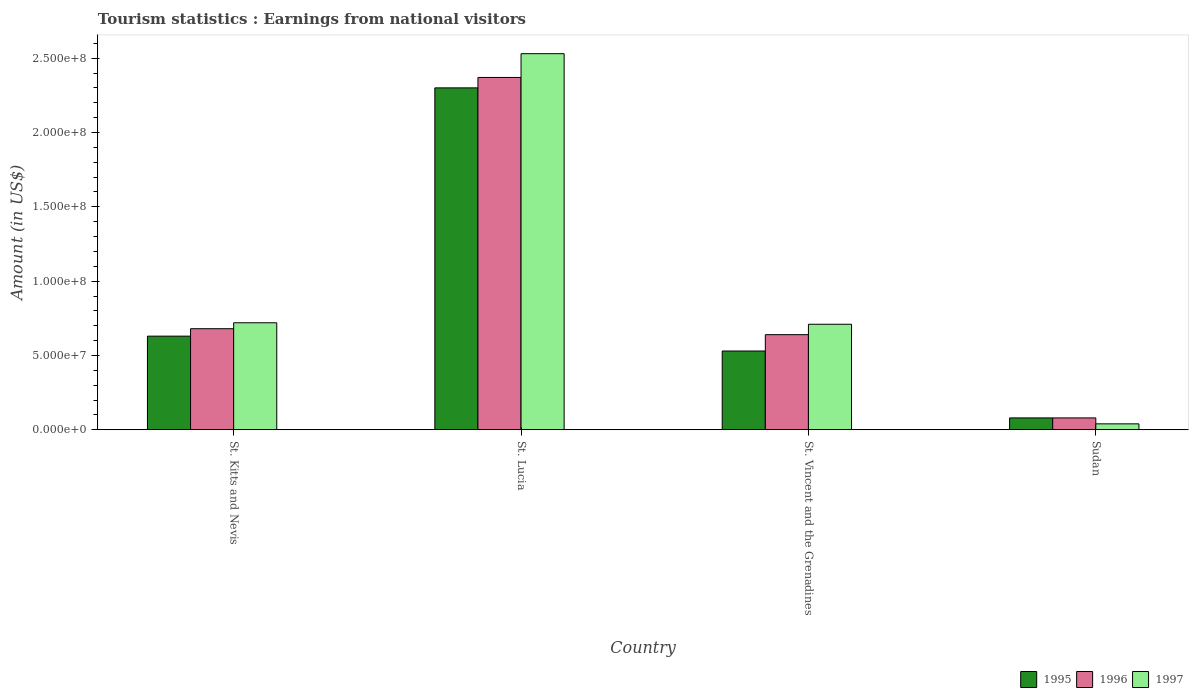How many different coloured bars are there?
Offer a very short reply. 3. How many groups of bars are there?
Ensure brevity in your answer.  4. How many bars are there on the 3rd tick from the right?
Your answer should be very brief. 3. What is the label of the 1st group of bars from the left?
Make the answer very short. St. Kitts and Nevis. Across all countries, what is the maximum earnings from national visitors in 1996?
Your answer should be very brief. 2.37e+08. Across all countries, what is the minimum earnings from national visitors in 1996?
Make the answer very short. 8.00e+06. In which country was the earnings from national visitors in 1997 maximum?
Make the answer very short. St. Lucia. In which country was the earnings from national visitors in 1995 minimum?
Offer a very short reply. Sudan. What is the total earnings from national visitors in 1997 in the graph?
Your response must be concise. 4.00e+08. What is the difference between the earnings from national visitors in 1997 in St. Lucia and that in Sudan?
Your answer should be compact. 2.49e+08. What is the difference between the earnings from national visitors in 1996 in St. Vincent and the Grenadines and the earnings from national visitors in 1997 in Sudan?
Provide a short and direct response. 6.00e+07. What is the average earnings from national visitors in 1995 per country?
Your answer should be very brief. 8.85e+07. What is the difference between the earnings from national visitors of/in 1995 and earnings from national visitors of/in 1996 in St. Kitts and Nevis?
Keep it short and to the point. -5.00e+06. What is the ratio of the earnings from national visitors in 1995 in St. Kitts and Nevis to that in Sudan?
Provide a short and direct response. 7.88. What is the difference between the highest and the second highest earnings from national visitors in 1995?
Your answer should be very brief. 1.77e+08. What is the difference between the highest and the lowest earnings from national visitors in 1996?
Offer a very short reply. 2.29e+08. Is the sum of the earnings from national visitors in 1996 in St. Lucia and St. Vincent and the Grenadines greater than the maximum earnings from national visitors in 1995 across all countries?
Provide a short and direct response. Yes. Is it the case that in every country, the sum of the earnings from national visitors in 1997 and earnings from national visitors in 1996 is greater than the earnings from national visitors in 1995?
Give a very brief answer. Yes. How many bars are there?
Ensure brevity in your answer.  12. How many countries are there in the graph?
Keep it short and to the point. 4. Does the graph contain any zero values?
Give a very brief answer. No. Does the graph contain grids?
Provide a succinct answer. No. Where does the legend appear in the graph?
Offer a very short reply. Bottom right. How many legend labels are there?
Make the answer very short. 3. What is the title of the graph?
Your answer should be compact. Tourism statistics : Earnings from national visitors. What is the label or title of the X-axis?
Your answer should be very brief. Country. What is the label or title of the Y-axis?
Your answer should be compact. Amount (in US$). What is the Amount (in US$) in 1995 in St. Kitts and Nevis?
Give a very brief answer. 6.30e+07. What is the Amount (in US$) in 1996 in St. Kitts and Nevis?
Ensure brevity in your answer.  6.80e+07. What is the Amount (in US$) in 1997 in St. Kitts and Nevis?
Keep it short and to the point. 7.20e+07. What is the Amount (in US$) in 1995 in St. Lucia?
Your answer should be very brief. 2.30e+08. What is the Amount (in US$) in 1996 in St. Lucia?
Offer a very short reply. 2.37e+08. What is the Amount (in US$) in 1997 in St. Lucia?
Offer a very short reply. 2.53e+08. What is the Amount (in US$) in 1995 in St. Vincent and the Grenadines?
Offer a terse response. 5.30e+07. What is the Amount (in US$) in 1996 in St. Vincent and the Grenadines?
Offer a very short reply. 6.40e+07. What is the Amount (in US$) of 1997 in St. Vincent and the Grenadines?
Provide a short and direct response. 7.10e+07. What is the Amount (in US$) in 1995 in Sudan?
Offer a terse response. 8.00e+06. Across all countries, what is the maximum Amount (in US$) in 1995?
Your answer should be compact. 2.30e+08. Across all countries, what is the maximum Amount (in US$) in 1996?
Offer a very short reply. 2.37e+08. Across all countries, what is the maximum Amount (in US$) in 1997?
Provide a succinct answer. 2.53e+08. Across all countries, what is the minimum Amount (in US$) of 1996?
Your answer should be compact. 8.00e+06. Across all countries, what is the minimum Amount (in US$) of 1997?
Ensure brevity in your answer.  4.00e+06. What is the total Amount (in US$) in 1995 in the graph?
Your answer should be very brief. 3.54e+08. What is the total Amount (in US$) in 1996 in the graph?
Offer a terse response. 3.77e+08. What is the total Amount (in US$) of 1997 in the graph?
Offer a terse response. 4.00e+08. What is the difference between the Amount (in US$) in 1995 in St. Kitts and Nevis and that in St. Lucia?
Your answer should be very brief. -1.67e+08. What is the difference between the Amount (in US$) in 1996 in St. Kitts and Nevis and that in St. Lucia?
Give a very brief answer. -1.69e+08. What is the difference between the Amount (in US$) in 1997 in St. Kitts and Nevis and that in St. Lucia?
Ensure brevity in your answer.  -1.81e+08. What is the difference between the Amount (in US$) in 1995 in St. Kitts and Nevis and that in St. Vincent and the Grenadines?
Offer a very short reply. 1.00e+07. What is the difference between the Amount (in US$) of 1996 in St. Kitts and Nevis and that in St. Vincent and the Grenadines?
Your response must be concise. 4.00e+06. What is the difference between the Amount (in US$) in 1995 in St. Kitts and Nevis and that in Sudan?
Offer a terse response. 5.50e+07. What is the difference between the Amount (in US$) of 1996 in St. Kitts and Nevis and that in Sudan?
Offer a terse response. 6.00e+07. What is the difference between the Amount (in US$) of 1997 in St. Kitts and Nevis and that in Sudan?
Your answer should be very brief. 6.80e+07. What is the difference between the Amount (in US$) in 1995 in St. Lucia and that in St. Vincent and the Grenadines?
Make the answer very short. 1.77e+08. What is the difference between the Amount (in US$) of 1996 in St. Lucia and that in St. Vincent and the Grenadines?
Offer a very short reply. 1.73e+08. What is the difference between the Amount (in US$) of 1997 in St. Lucia and that in St. Vincent and the Grenadines?
Ensure brevity in your answer.  1.82e+08. What is the difference between the Amount (in US$) of 1995 in St. Lucia and that in Sudan?
Provide a short and direct response. 2.22e+08. What is the difference between the Amount (in US$) of 1996 in St. Lucia and that in Sudan?
Your answer should be very brief. 2.29e+08. What is the difference between the Amount (in US$) of 1997 in St. Lucia and that in Sudan?
Keep it short and to the point. 2.49e+08. What is the difference between the Amount (in US$) of 1995 in St. Vincent and the Grenadines and that in Sudan?
Offer a terse response. 4.50e+07. What is the difference between the Amount (in US$) in 1996 in St. Vincent and the Grenadines and that in Sudan?
Ensure brevity in your answer.  5.60e+07. What is the difference between the Amount (in US$) of 1997 in St. Vincent and the Grenadines and that in Sudan?
Provide a succinct answer. 6.70e+07. What is the difference between the Amount (in US$) of 1995 in St. Kitts and Nevis and the Amount (in US$) of 1996 in St. Lucia?
Your response must be concise. -1.74e+08. What is the difference between the Amount (in US$) in 1995 in St. Kitts and Nevis and the Amount (in US$) in 1997 in St. Lucia?
Provide a short and direct response. -1.90e+08. What is the difference between the Amount (in US$) of 1996 in St. Kitts and Nevis and the Amount (in US$) of 1997 in St. Lucia?
Your answer should be compact. -1.85e+08. What is the difference between the Amount (in US$) in 1995 in St. Kitts and Nevis and the Amount (in US$) in 1996 in St. Vincent and the Grenadines?
Give a very brief answer. -1.00e+06. What is the difference between the Amount (in US$) of 1995 in St. Kitts and Nevis and the Amount (in US$) of 1997 in St. Vincent and the Grenadines?
Ensure brevity in your answer.  -8.00e+06. What is the difference between the Amount (in US$) in 1995 in St. Kitts and Nevis and the Amount (in US$) in 1996 in Sudan?
Your answer should be very brief. 5.50e+07. What is the difference between the Amount (in US$) of 1995 in St. Kitts and Nevis and the Amount (in US$) of 1997 in Sudan?
Keep it short and to the point. 5.90e+07. What is the difference between the Amount (in US$) of 1996 in St. Kitts and Nevis and the Amount (in US$) of 1997 in Sudan?
Keep it short and to the point. 6.40e+07. What is the difference between the Amount (in US$) of 1995 in St. Lucia and the Amount (in US$) of 1996 in St. Vincent and the Grenadines?
Your answer should be compact. 1.66e+08. What is the difference between the Amount (in US$) of 1995 in St. Lucia and the Amount (in US$) of 1997 in St. Vincent and the Grenadines?
Give a very brief answer. 1.59e+08. What is the difference between the Amount (in US$) of 1996 in St. Lucia and the Amount (in US$) of 1997 in St. Vincent and the Grenadines?
Your answer should be very brief. 1.66e+08. What is the difference between the Amount (in US$) in 1995 in St. Lucia and the Amount (in US$) in 1996 in Sudan?
Offer a terse response. 2.22e+08. What is the difference between the Amount (in US$) in 1995 in St. Lucia and the Amount (in US$) in 1997 in Sudan?
Your answer should be very brief. 2.26e+08. What is the difference between the Amount (in US$) of 1996 in St. Lucia and the Amount (in US$) of 1997 in Sudan?
Make the answer very short. 2.33e+08. What is the difference between the Amount (in US$) of 1995 in St. Vincent and the Grenadines and the Amount (in US$) of 1996 in Sudan?
Your answer should be very brief. 4.50e+07. What is the difference between the Amount (in US$) in 1995 in St. Vincent and the Grenadines and the Amount (in US$) in 1997 in Sudan?
Your answer should be compact. 4.90e+07. What is the difference between the Amount (in US$) in 1996 in St. Vincent and the Grenadines and the Amount (in US$) in 1997 in Sudan?
Provide a succinct answer. 6.00e+07. What is the average Amount (in US$) of 1995 per country?
Your answer should be very brief. 8.85e+07. What is the average Amount (in US$) of 1996 per country?
Your answer should be very brief. 9.42e+07. What is the average Amount (in US$) of 1997 per country?
Provide a short and direct response. 1.00e+08. What is the difference between the Amount (in US$) of 1995 and Amount (in US$) of 1996 in St. Kitts and Nevis?
Your response must be concise. -5.00e+06. What is the difference between the Amount (in US$) in 1995 and Amount (in US$) in 1997 in St. Kitts and Nevis?
Offer a very short reply. -9.00e+06. What is the difference between the Amount (in US$) of 1995 and Amount (in US$) of 1996 in St. Lucia?
Make the answer very short. -7.00e+06. What is the difference between the Amount (in US$) in 1995 and Amount (in US$) in 1997 in St. Lucia?
Keep it short and to the point. -2.30e+07. What is the difference between the Amount (in US$) in 1996 and Amount (in US$) in 1997 in St. Lucia?
Your answer should be very brief. -1.60e+07. What is the difference between the Amount (in US$) in 1995 and Amount (in US$) in 1996 in St. Vincent and the Grenadines?
Your answer should be very brief. -1.10e+07. What is the difference between the Amount (in US$) in 1995 and Amount (in US$) in 1997 in St. Vincent and the Grenadines?
Keep it short and to the point. -1.80e+07. What is the difference between the Amount (in US$) of 1996 and Amount (in US$) of 1997 in St. Vincent and the Grenadines?
Make the answer very short. -7.00e+06. What is the difference between the Amount (in US$) of 1995 and Amount (in US$) of 1997 in Sudan?
Keep it short and to the point. 4.00e+06. What is the difference between the Amount (in US$) in 1996 and Amount (in US$) in 1997 in Sudan?
Provide a short and direct response. 4.00e+06. What is the ratio of the Amount (in US$) in 1995 in St. Kitts and Nevis to that in St. Lucia?
Your response must be concise. 0.27. What is the ratio of the Amount (in US$) of 1996 in St. Kitts and Nevis to that in St. Lucia?
Offer a very short reply. 0.29. What is the ratio of the Amount (in US$) of 1997 in St. Kitts and Nevis to that in St. Lucia?
Ensure brevity in your answer.  0.28. What is the ratio of the Amount (in US$) of 1995 in St. Kitts and Nevis to that in St. Vincent and the Grenadines?
Give a very brief answer. 1.19. What is the ratio of the Amount (in US$) of 1996 in St. Kitts and Nevis to that in St. Vincent and the Grenadines?
Your answer should be compact. 1.06. What is the ratio of the Amount (in US$) of 1997 in St. Kitts and Nevis to that in St. Vincent and the Grenadines?
Provide a succinct answer. 1.01. What is the ratio of the Amount (in US$) of 1995 in St. Kitts and Nevis to that in Sudan?
Your response must be concise. 7.88. What is the ratio of the Amount (in US$) of 1996 in St. Kitts and Nevis to that in Sudan?
Give a very brief answer. 8.5. What is the ratio of the Amount (in US$) in 1995 in St. Lucia to that in St. Vincent and the Grenadines?
Offer a very short reply. 4.34. What is the ratio of the Amount (in US$) in 1996 in St. Lucia to that in St. Vincent and the Grenadines?
Provide a short and direct response. 3.7. What is the ratio of the Amount (in US$) of 1997 in St. Lucia to that in St. Vincent and the Grenadines?
Offer a very short reply. 3.56. What is the ratio of the Amount (in US$) of 1995 in St. Lucia to that in Sudan?
Your response must be concise. 28.75. What is the ratio of the Amount (in US$) of 1996 in St. Lucia to that in Sudan?
Your response must be concise. 29.62. What is the ratio of the Amount (in US$) of 1997 in St. Lucia to that in Sudan?
Offer a terse response. 63.25. What is the ratio of the Amount (in US$) of 1995 in St. Vincent and the Grenadines to that in Sudan?
Ensure brevity in your answer.  6.62. What is the ratio of the Amount (in US$) of 1997 in St. Vincent and the Grenadines to that in Sudan?
Your response must be concise. 17.75. What is the difference between the highest and the second highest Amount (in US$) in 1995?
Make the answer very short. 1.67e+08. What is the difference between the highest and the second highest Amount (in US$) of 1996?
Make the answer very short. 1.69e+08. What is the difference between the highest and the second highest Amount (in US$) of 1997?
Your answer should be very brief. 1.81e+08. What is the difference between the highest and the lowest Amount (in US$) of 1995?
Offer a terse response. 2.22e+08. What is the difference between the highest and the lowest Amount (in US$) in 1996?
Your answer should be compact. 2.29e+08. What is the difference between the highest and the lowest Amount (in US$) in 1997?
Make the answer very short. 2.49e+08. 